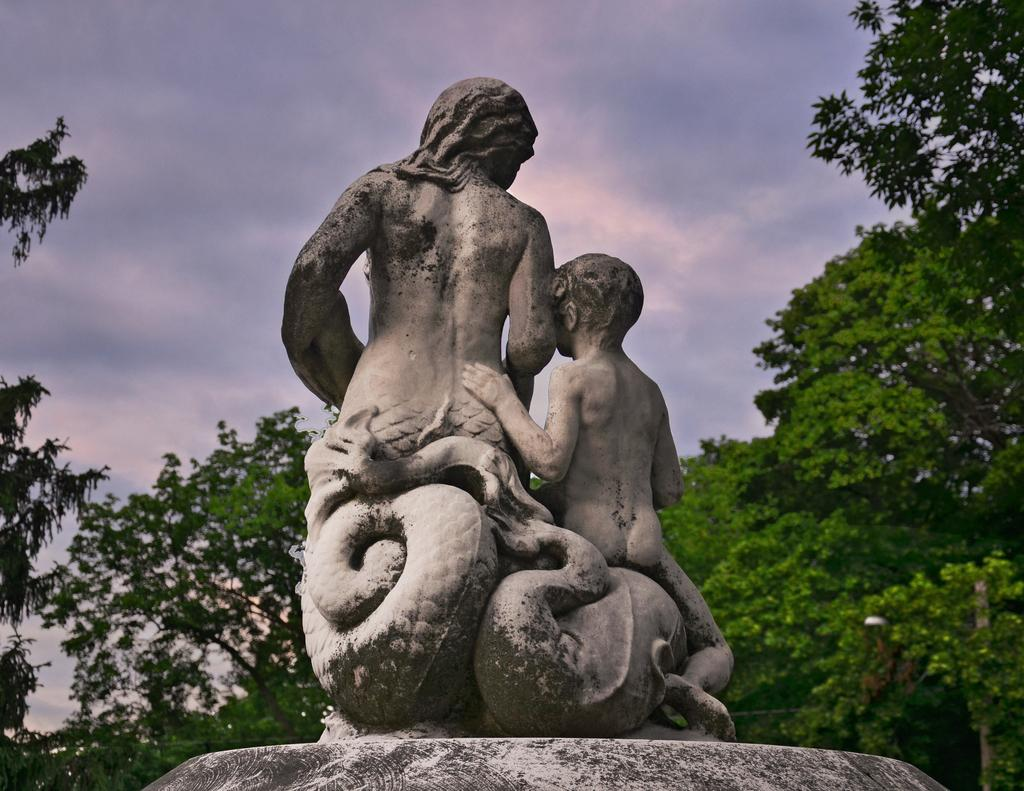What is the main subject in the image? There is a statue in the image. What other elements can be seen in the image? There are trees in the image. What can be seen in the background of the image? The sky is visible in the background of the image. Are there any weather conditions visible in the image? Yes, clouds are present in the sky. How many friends are sitting on the plate in the image? There is no plate or friends present in the image. 